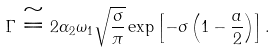Convert formula to latex. <formula><loc_0><loc_0><loc_500><loc_500>\Gamma \cong 2 \alpha _ { 2 } \omega _ { 1 } \sqrt { \frac { \sigma } { \pi } } \exp \left [ - \sigma \left ( 1 - \frac { a } { 2 } \right ) \right ] .</formula> 